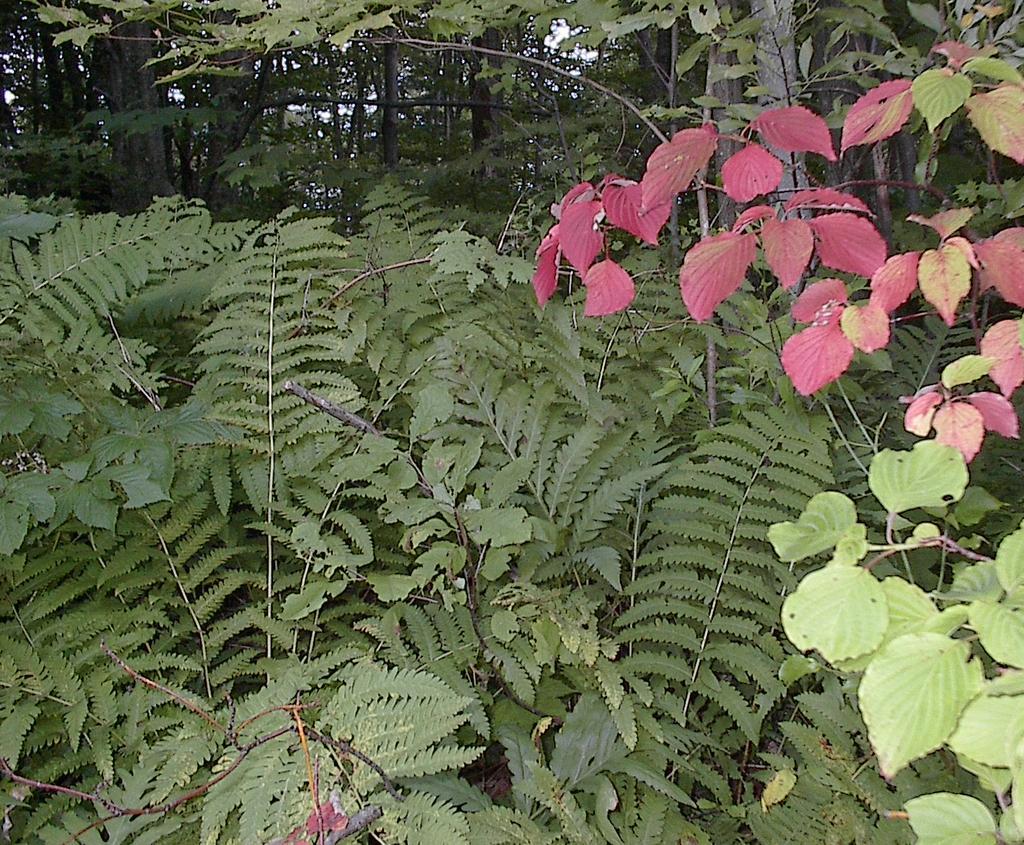In one or two sentences, can you explain what this image depicts? In this image we can see trees. 